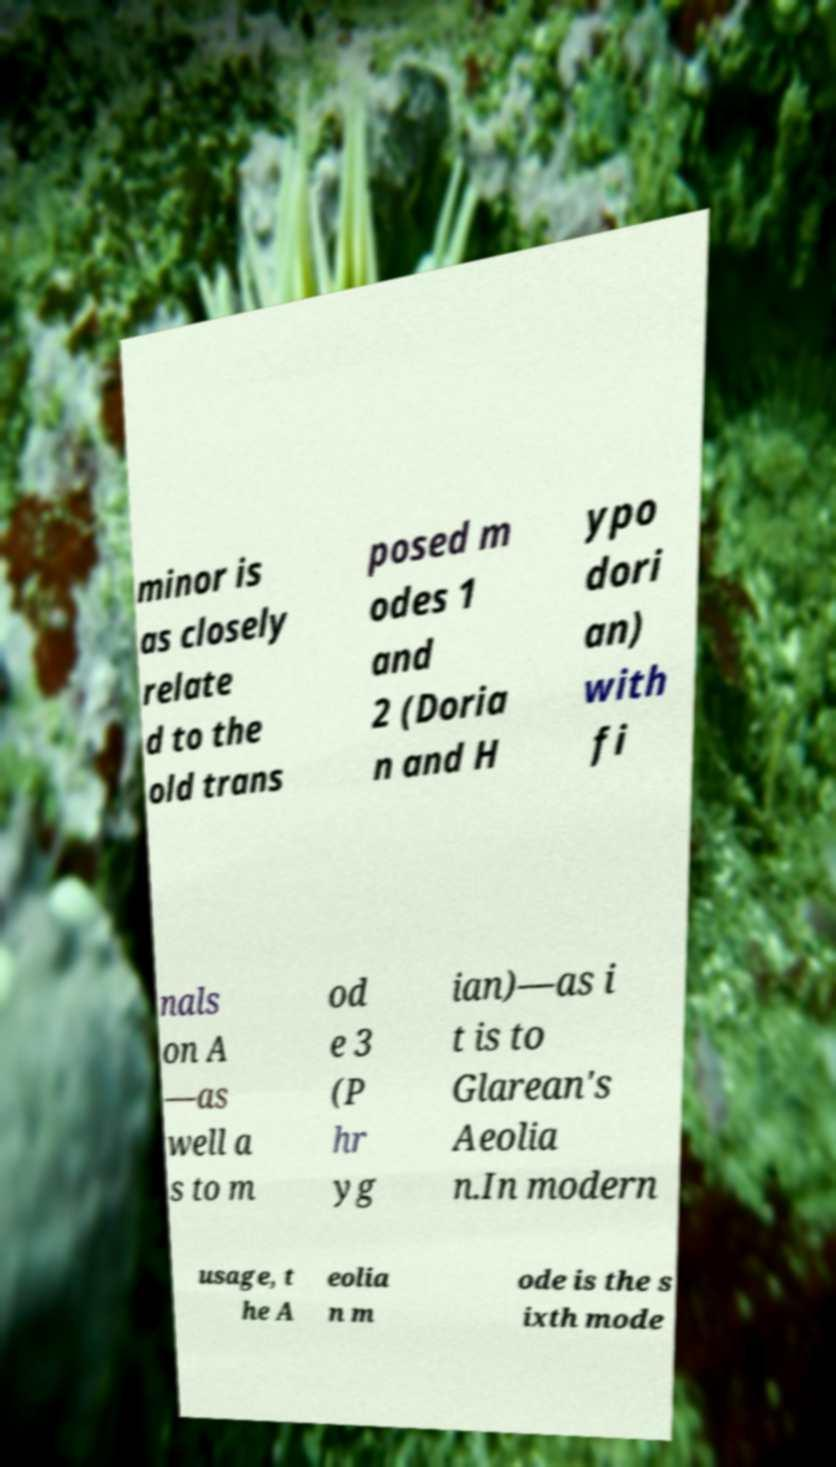Could you assist in decoding the text presented in this image and type it out clearly? minor is as closely relate d to the old trans posed m odes 1 and 2 (Doria n and H ypo dori an) with fi nals on A —as well a s to m od e 3 (P hr yg ian)—as i t is to Glarean's Aeolia n.In modern usage, t he A eolia n m ode is the s ixth mode 